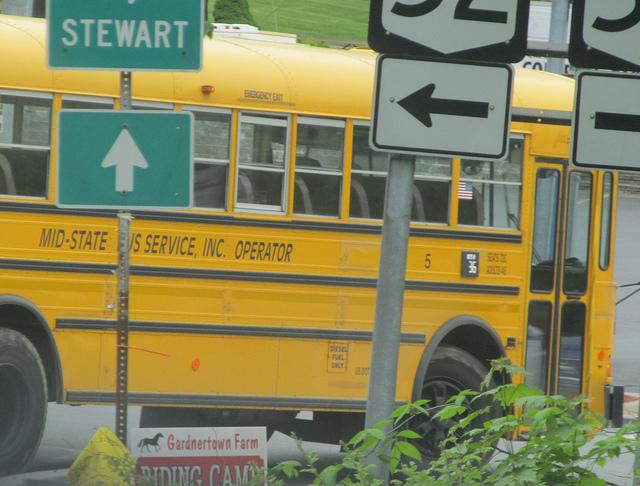How many arrows do you see in this picture?
Give a very brief answer. 2. What does the bus sign say?
Quick response, please. Mid-state service, inc operator. Are all the arrows pointing in the same direction?
Keep it brief. No. 